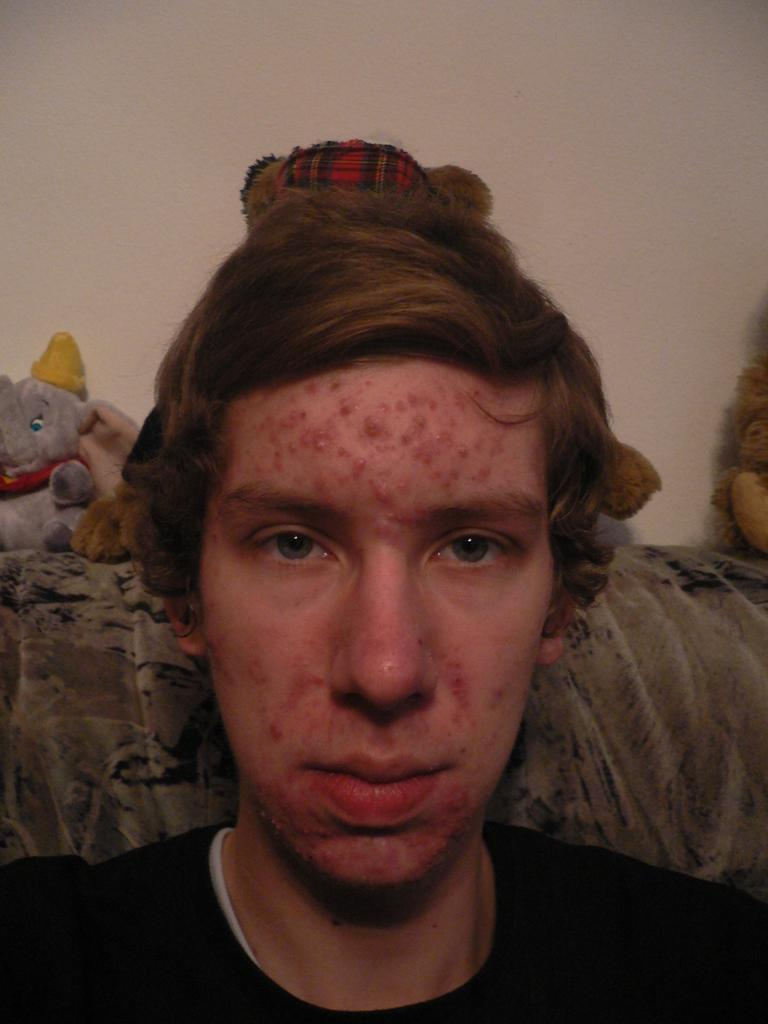What is the person in the image doing? There is a person sitting on a couch in the image. What can be seen behind the person in the image? There are toys behind the person in the image. What is visible in the background of the image? There is a wall in the background of the image. What is the person's level of anger in the image? There is no indication of the person's emotions in the image, so it cannot be determined if they are angry or not. 